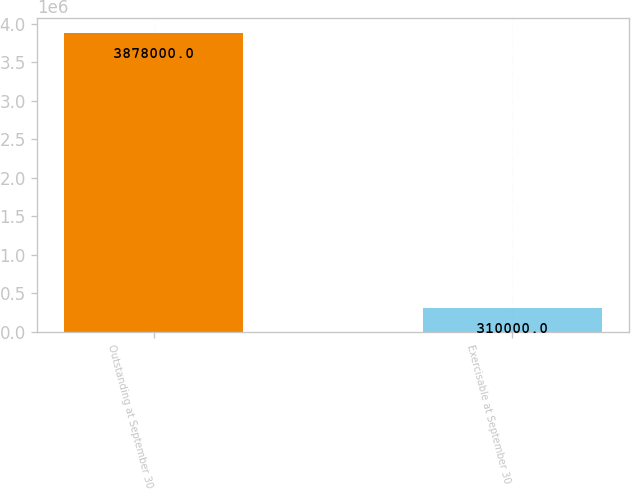<chart> <loc_0><loc_0><loc_500><loc_500><bar_chart><fcel>Outstanding at September 30<fcel>Exercisable at September 30<nl><fcel>3.878e+06<fcel>310000<nl></chart> 